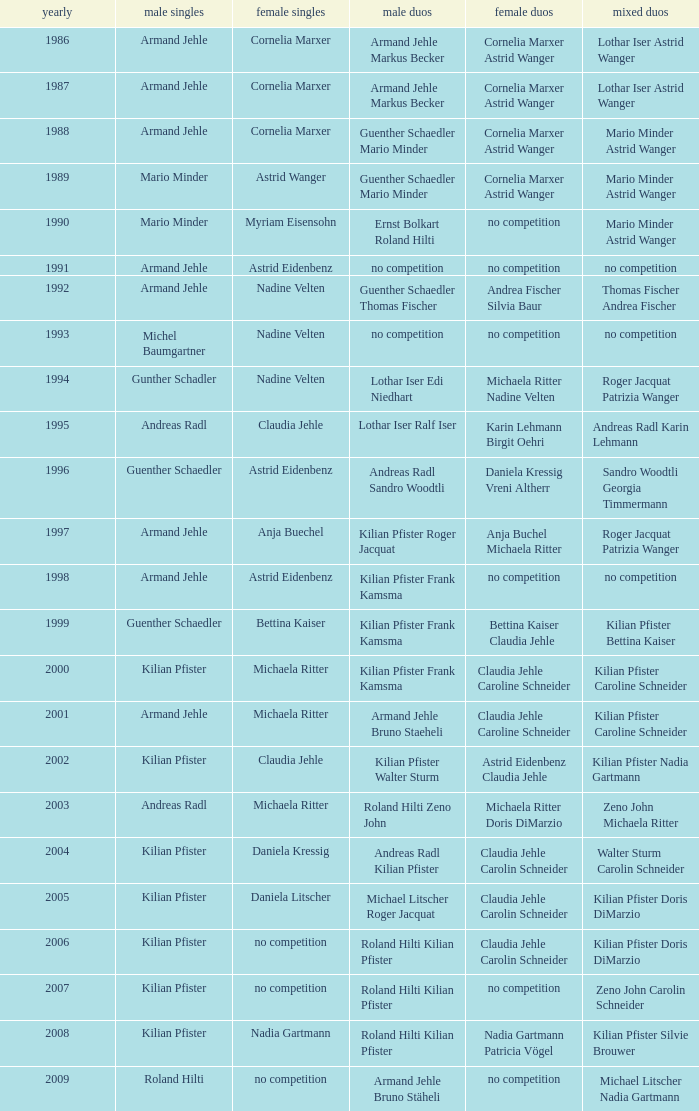In 2004, where the womens singles is daniela kressig who is the mens singles Kilian Pfister. 